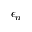<formula> <loc_0><loc_0><loc_500><loc_500>\epsilon _ { n }</formula> 